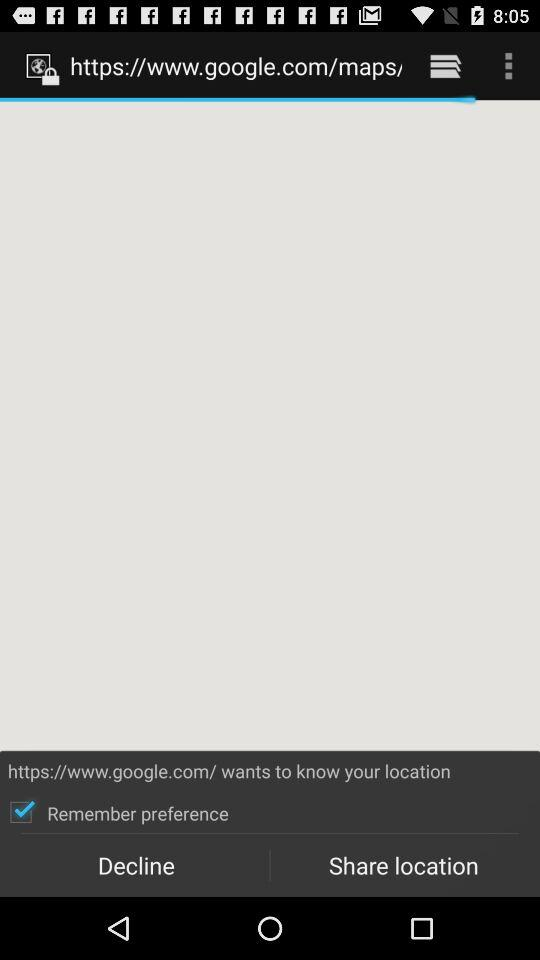What is the status of "Remember preference"? The status is "on". 